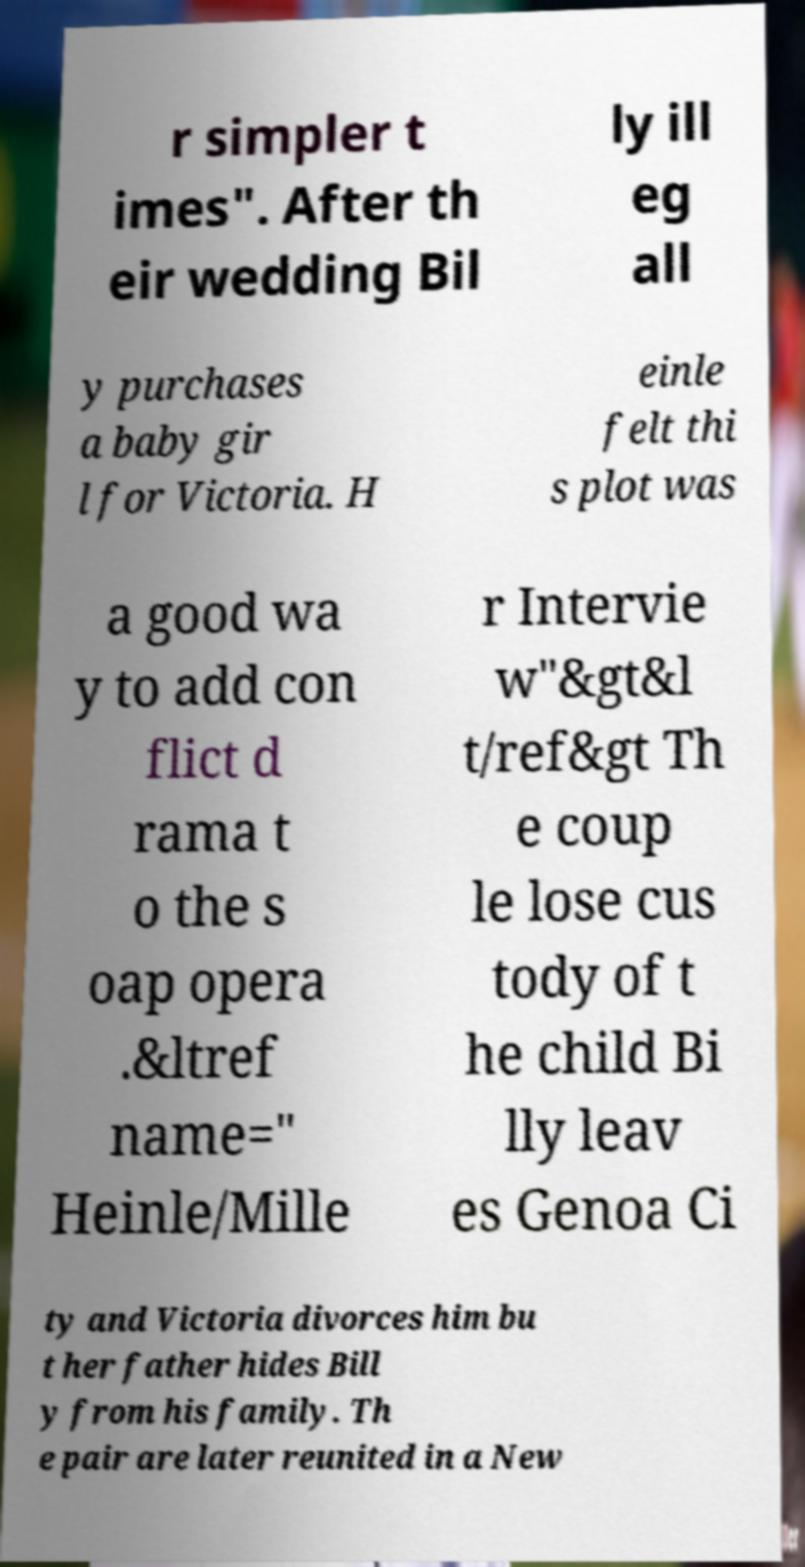Can you read and provide the text displayed in the image?This photo seems to have some interesting text. Can you extract and type it out for me? r simpler t imes". After th eir wedding Bil ly ill eg all y purchases a baby gir l for Victoria. H einle felt thi s plot was a good wa y to add con flict d rama t o the s oap opera .&ltref name=" Heinle/Mille r Intervie w"&gt&l t/ref&gt Th e coup le lose cus tody of t he child Bi lly leav es Genoa Ci ty and Victoria divorces him bu t her father hides Bill y from his family. Th e pair are later reunited in a New 